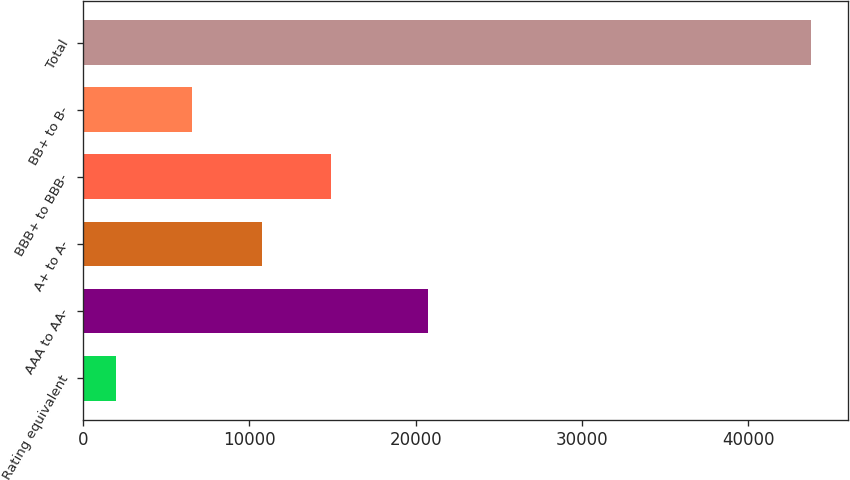Convert chart to OTSL. <chart><loc_0><loc_0><loc_500><loc_500><bar_chart><fcel>Rating equivalent<fcel>AAA to AA-<fcel>A+ to A-<fcel>BBB+ to BBB-<fcel>BB+ to B-<fcel>Total<nl><fcel>2005<fcel>20735<fcel>10758.2<fcel>14936.4<fcel>6580<fcel>43787<nl></chart> 